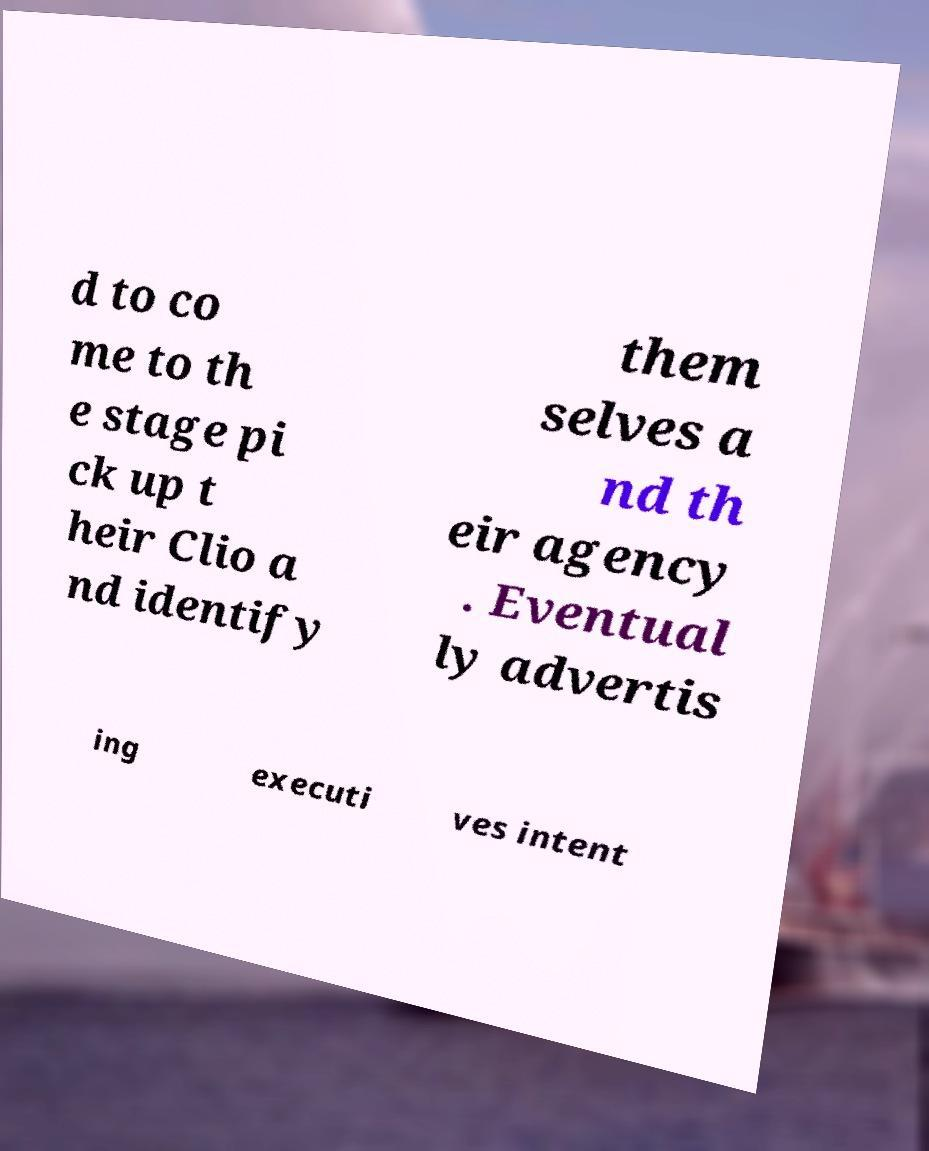Can you accurately transcribe the text from the provided image for me? d to co me to th e stage pi ck up t heir Clio a nd identify them selves a nd th eir agency . Eventual ly advertis ing executi ves intent 